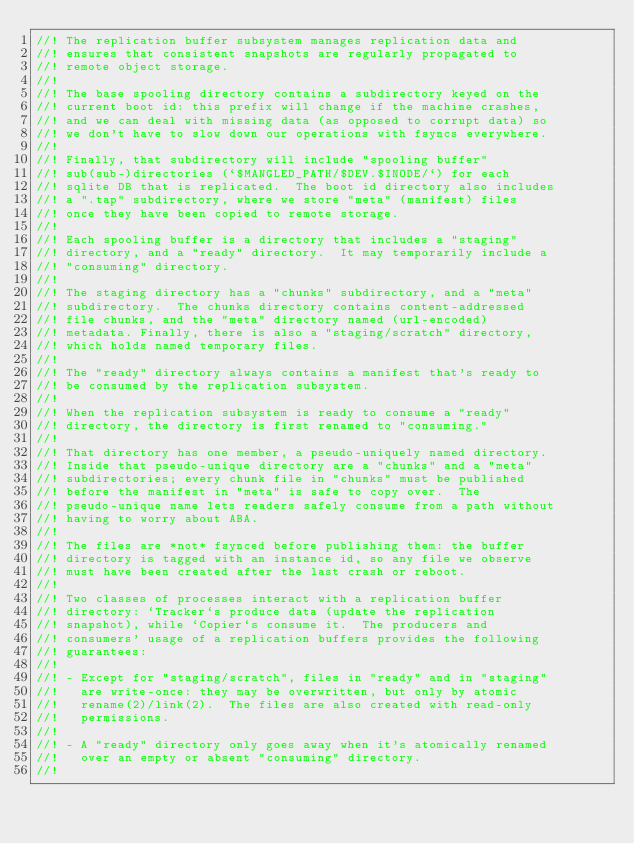<code> <loc_0><loc_0><loc_500><loc_500><_Rust_>//! The replication buffer subsystem manages replication data and
//! ensures that consistent snapshots are regularly propagated to
//! remote object storage.
//!
//! The base spooling directory contains a subdirectory keyed on the
//! current boot id: this prefix will change if the machine crashes,
//! and we can deal with missing data (as opposed to corrupt data) so
//! we don't have to slow down our operations with fsyncs everywhere.
//!
//! Finally, that subdirectory will include "spooling buffer"
//! sub(sub-)directories (`$MANGLED_PATH/$DEV.$INODE/`) for each
//! sqlite DB that is replicated.  The boot id directory also includes
//! a ".tap" subdirectory, where we store "meta" (manifest) files
//! once they have been copied to remote storage.
//!
//! Each spooling buffer is a directory that includes a "staging"
//! directory, and a "ready" directory.  It may temporarily include a
//! "consuming" directory.
//!
//! The staging directory has a "chunks" subdirectory, and a "meta"
//! subdirectory.  The chunks directory contains content-addressed
//! file chunks, and the "meta" directory named (url-encoded)
//! metadata. Finally, there is also a "staging/scratch" directory,
//! which holds named temporary files.
//!
//! The "ready" directory always contains a manifest that's ready to
//! be consumed by the replication subsystem.
//!
//! When the replication subsystem is ready to consume a "ready"
//! directory, the directory is first renamed to "consuming."
//!
//! That directory has one member, a pseudo-uniquely named directory.
//! Inside that pseudo-unique directory are a "chunks" and a "meta"
//! subdirectories; every chunk file in "chunks" must be published
//! before the manifest in "meta" is safe to copy over.  The
//! pseudo-unique name lets readers safely consume from a path without
//! having to worry about ABA.
//!
//! The files are *not* fsynced before publishing them: the buffer
//! directory is tagged with an instance id, so any file we observe
//! must have been created after the last crash or reboot.
//!
//! Two classes of processes interact with a replication buffer
//! directory: `Tracker`s produce data (update the replication
//! snapshot), while `Copier`s consume it.  The producers and
//! consumers' usage of a replication buffers provides the following
//! guarantees:
//!
//! - Except for "staging/scratch", files in "ready" and in "staging"
//!   are write-once: they may be overwritten, but only by atomic
//!   rename(2)/link(2).  The files are also created with read-only
//!   permissions.
//!
//! - A "ready" directory only goes away when it's atomically renamed
//!   over an empty or absent "consuming" directory.
//!</code> 